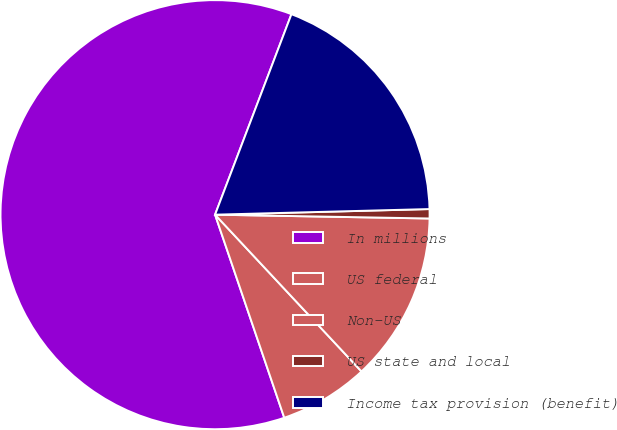Convert chart. <chart><loc_0><loc_0><loc_500><loc_500><pie_chart><fcel>In millions<fcel>US federal<fcel>Non-US<fcel>US state and local<fcel>Income tax provision (benefit)<nl><fcel>61.02%<fcel>6.73%<fcel>12.76%<fcel>0.7%<fcel>18.79%<nl></chart> 